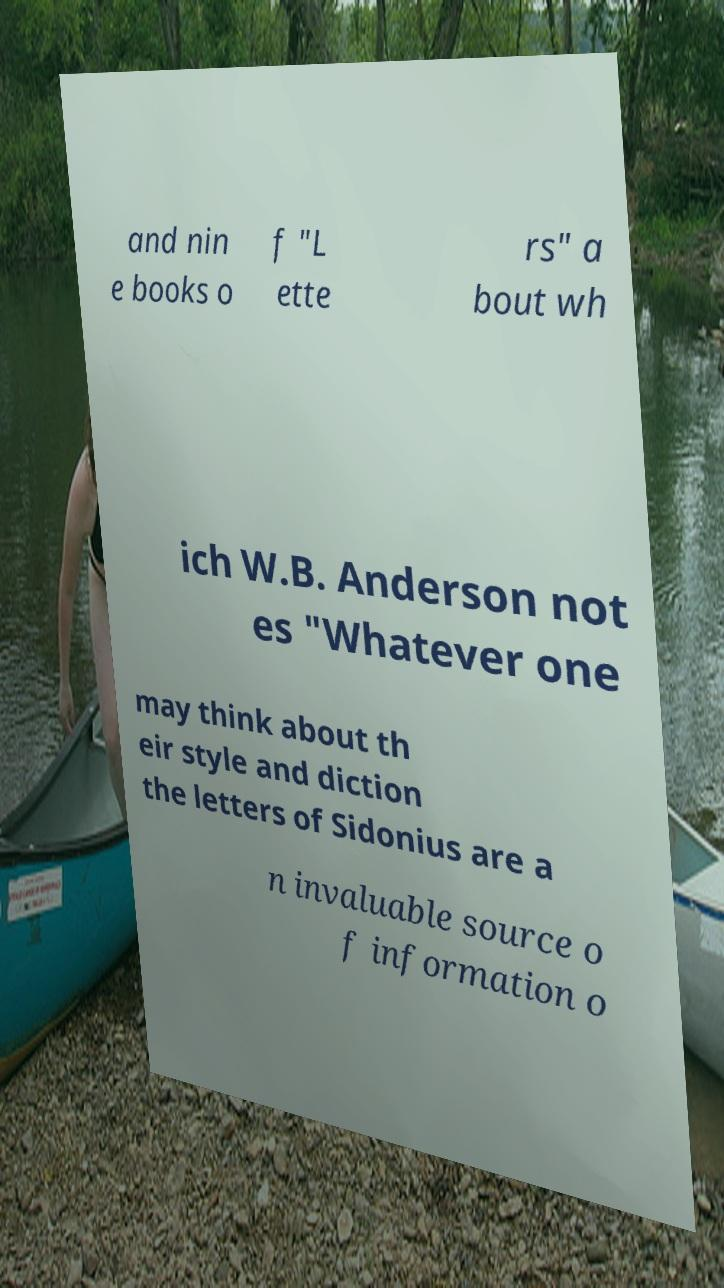Please read and relay the text visible in this image. What does it say? and nin e books o f "L ette rs" a bout wh ich W.B. Anderson not es "Whatever one may think about th eir style and diction the letters of Sidonius are a n invaluable source o f information o 